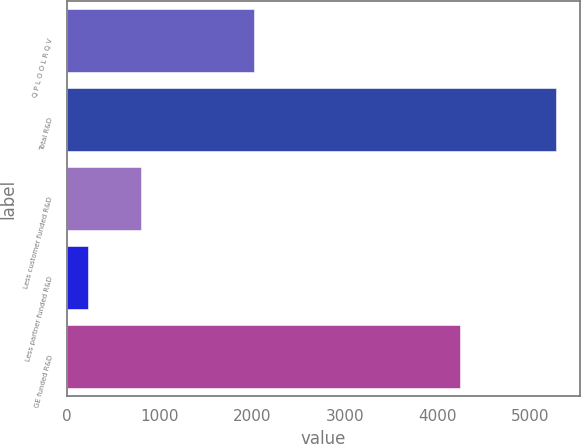Convert chart. <chart><loc_0><loc_0><loc_500><loc_500><bar_chart><fcel>Q P L O O L R Q V<fcel>Total R&D<fcel>Less customer funded R&D<fcel>Less partner funded R&D<fcel>GE funded R&D<nl><fcel>2015<fcel>5278<fcel>803<fcel>226<fcel>4249<nl></chart> 